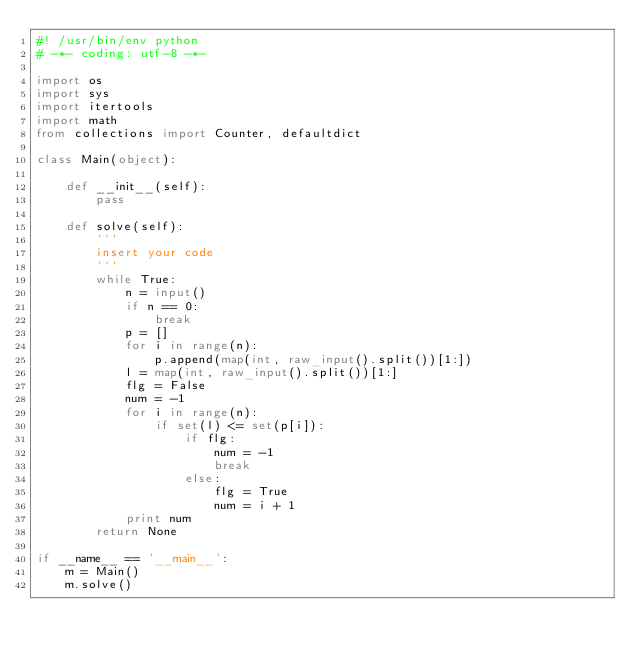<code> <loc_0><loc_0><loc_500><loc_500><_Python_>#! /usr/bin/env python
# -*- coding: utf-8 -*-

import os
import sys
import itertools
import math
from collections import Counter, defaultdict

class Main(object):
    
    def __init__(self):
        pass

    def solve(self):
        '''
        insert your code
        '''
        while True:
            n = input()
            if n == 0:
                break
            p = []
            for i in range(n):
                p.append(map(int, raw_input().split())[1:])
            l = map(int, raw_input().split())[1:]
            flg = False
            num = -1
            for i in range(n):
                if set(l) <= set(p[i]):
                    if flg:
                        num = -1
                        break
                    else:
                        flg = True
                        num = i + 1
            print num
        return None

if __name__ == '__main__':
    m = Main()
    m.solve()</code> 